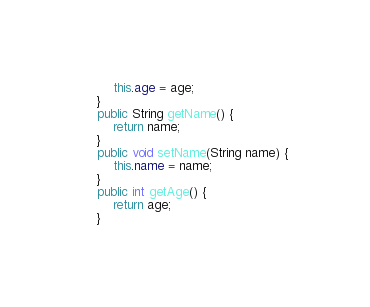Convert code to text. <code><loc_0><loc_0><loc_500><loc_500><_Java_>		this.age = age;
	}
	public String getName() {
		return name;
	}
	public void setName(String name) {
		this.name = name;
	}
	public int getAge() {
		return age;
	}</code> 